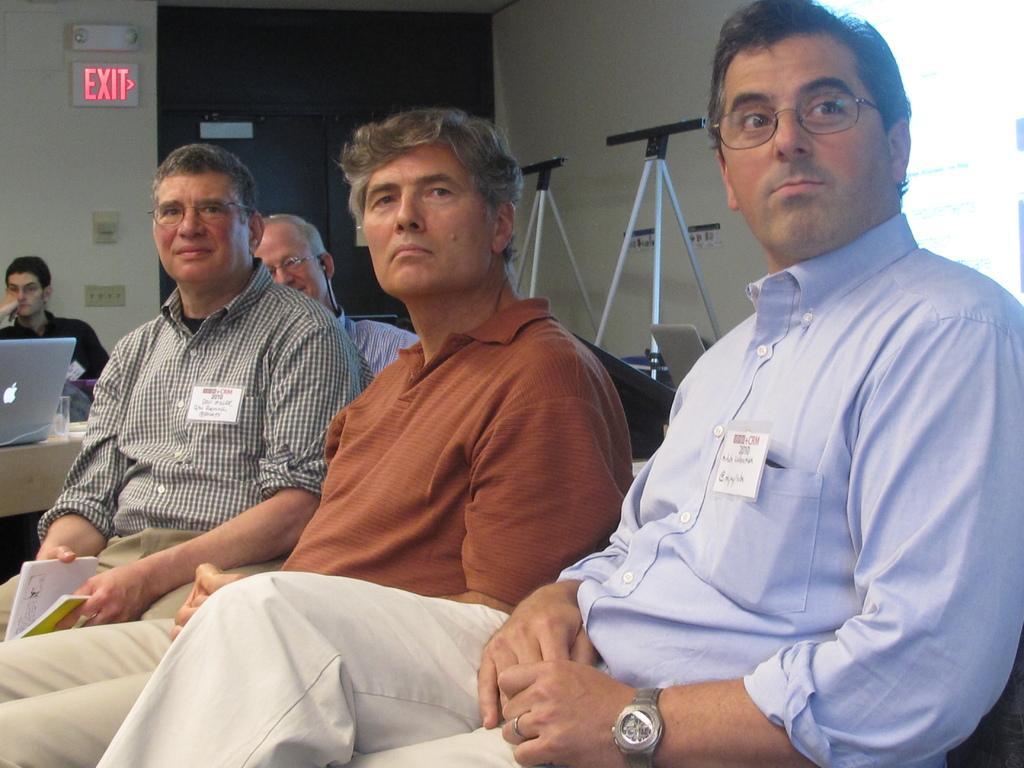In one or two sentences, can you explain what this image depicts? In this image we can see a group of people sitting on chairs. One person is holding a book in his hand. To the left side of the image we can see a laptop placed on the table. In the background, we can see some strands, sign board with some text and a door. 